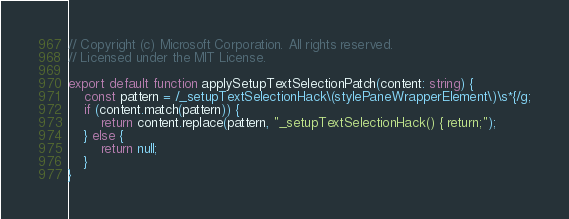<code> <loc_0><loc_0><loc_500><loc_500><_TypeScript_>// Copyright (c) Microsoft Corporation. All rights reserved.
// Licensed under the MIT License.

export default function applySetupTextSelectionPatch(content: string) {
    const pattern = /_setupTextSelectionHack\(stylePaneWrapperElement\)\s*{/g;
    if (content.match(pattern)) {
        return content.replace(pattern, "_setupTextSelectionHack() { return;");
    } else {
        return null;
    }
}
</code> 